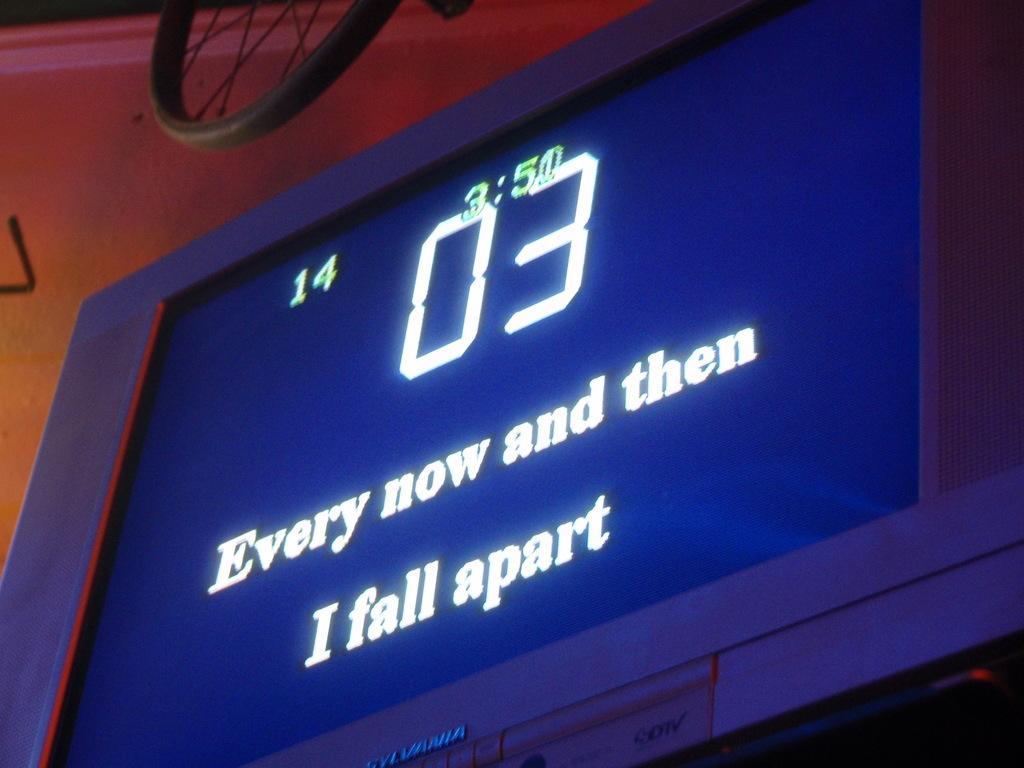<image>
Give a short and clear explanation of the subsequent image. A karaoke screen with the words 'Every now and then I fall apart' 